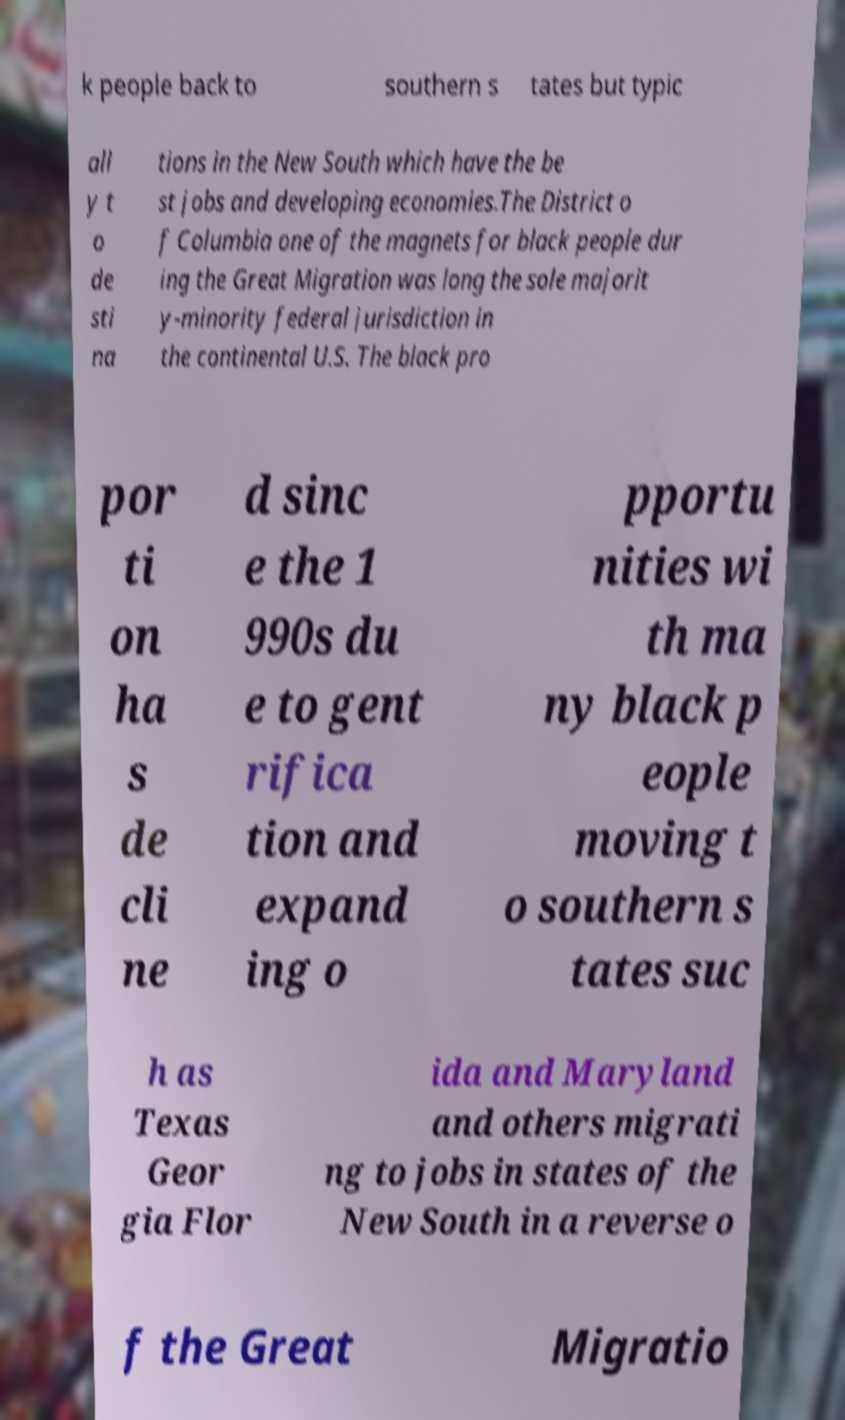What messages or text are displayed in this image? I need them in a readable, typed format. k people back to southern s tates but typic all y t o de sti na tions in the New South which have the be st jobs and developing economies.The District o f Columbia one of the magnets for black people dur ing the Great Migration was long the sole majorit y-minority federal jurisdiction in the continental U.S. The black pro por ti on ha s de cli ne d sinc e the 1 990s du e to gent rifica tion and expand ing o pportu nities wi th ma ny black p eople moving t o southern s tates suc h as Texas Geor gia Flor ida and Maryland and others migrati ng to jobs in states of the New South in a reverse o f the Great Migratio 